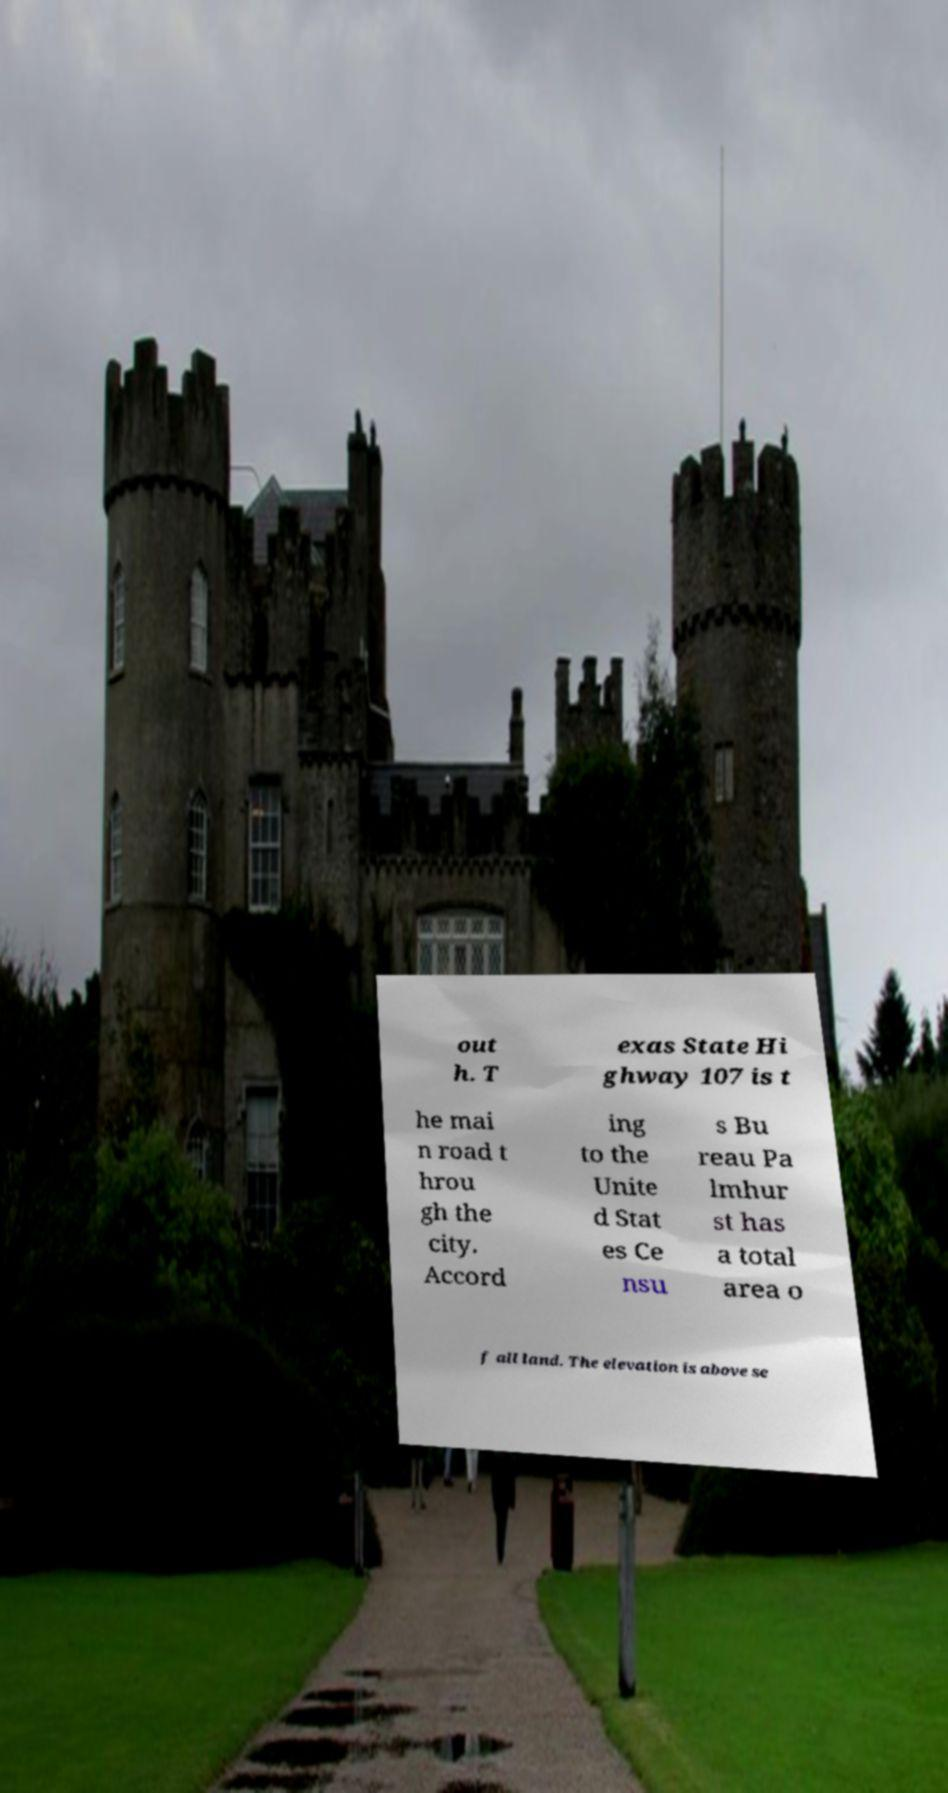Please read and relay the text visible in this image. What does it say? out h. T exas State Hi ghway 107 is t he mai n road t hrou gh the city. Accord ing to the Unite d Stat es Ce nsu s Bu reau Pa lmhur st has a total area o f all land. The elevation is above se 